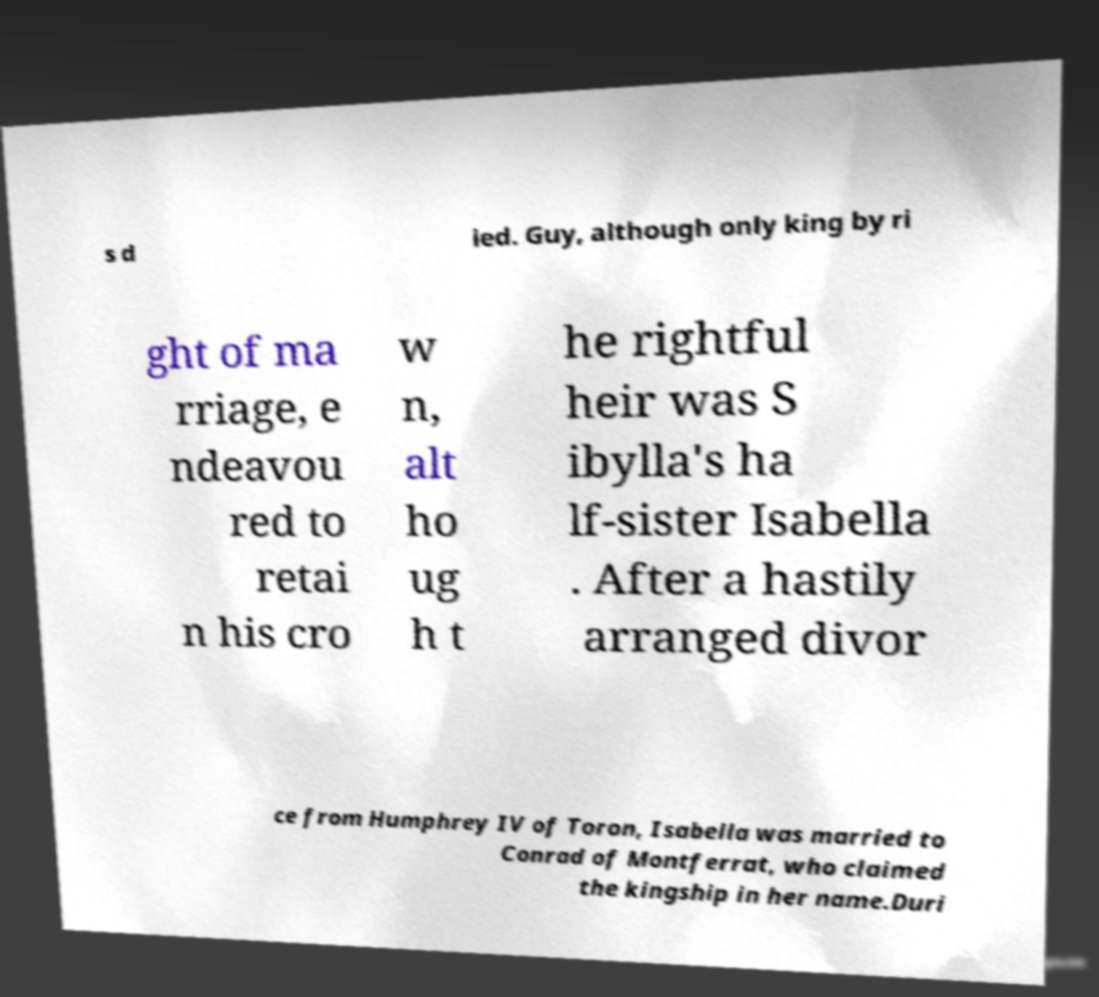What messages or text are displayed in this image? I need them in a readable, typed format. s d ied. Guy, although only king by ri ght of ma rriage, e ndeavou red to retai n his cro w n, alt ho ug h t he rightful heir was S ibylla's ha lf-sister Isabella . After a hastily arranged divor ce from Humphrey IV of Toron, Isabella was married to Conrad of Montferrat, who claimed the kingship in her name.Duri 